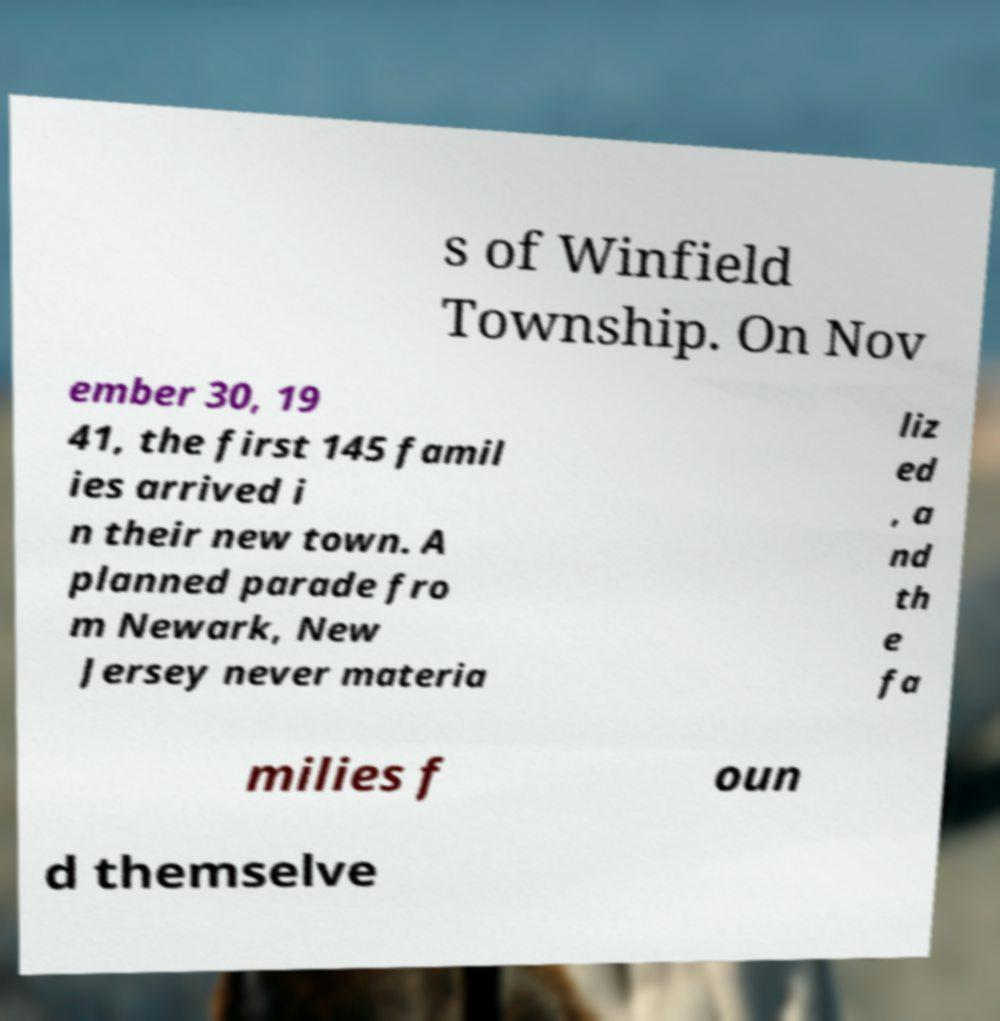Can you accurately transcribe the text from the provided image for me? s of Winfield Township. On Nov ember 30, 19 41, the first 145 famil ies arrived i n their new town. A planned parade fro m Newark, New Jersey never materia liz ed , a nd th e fa milies f oun d themselve 